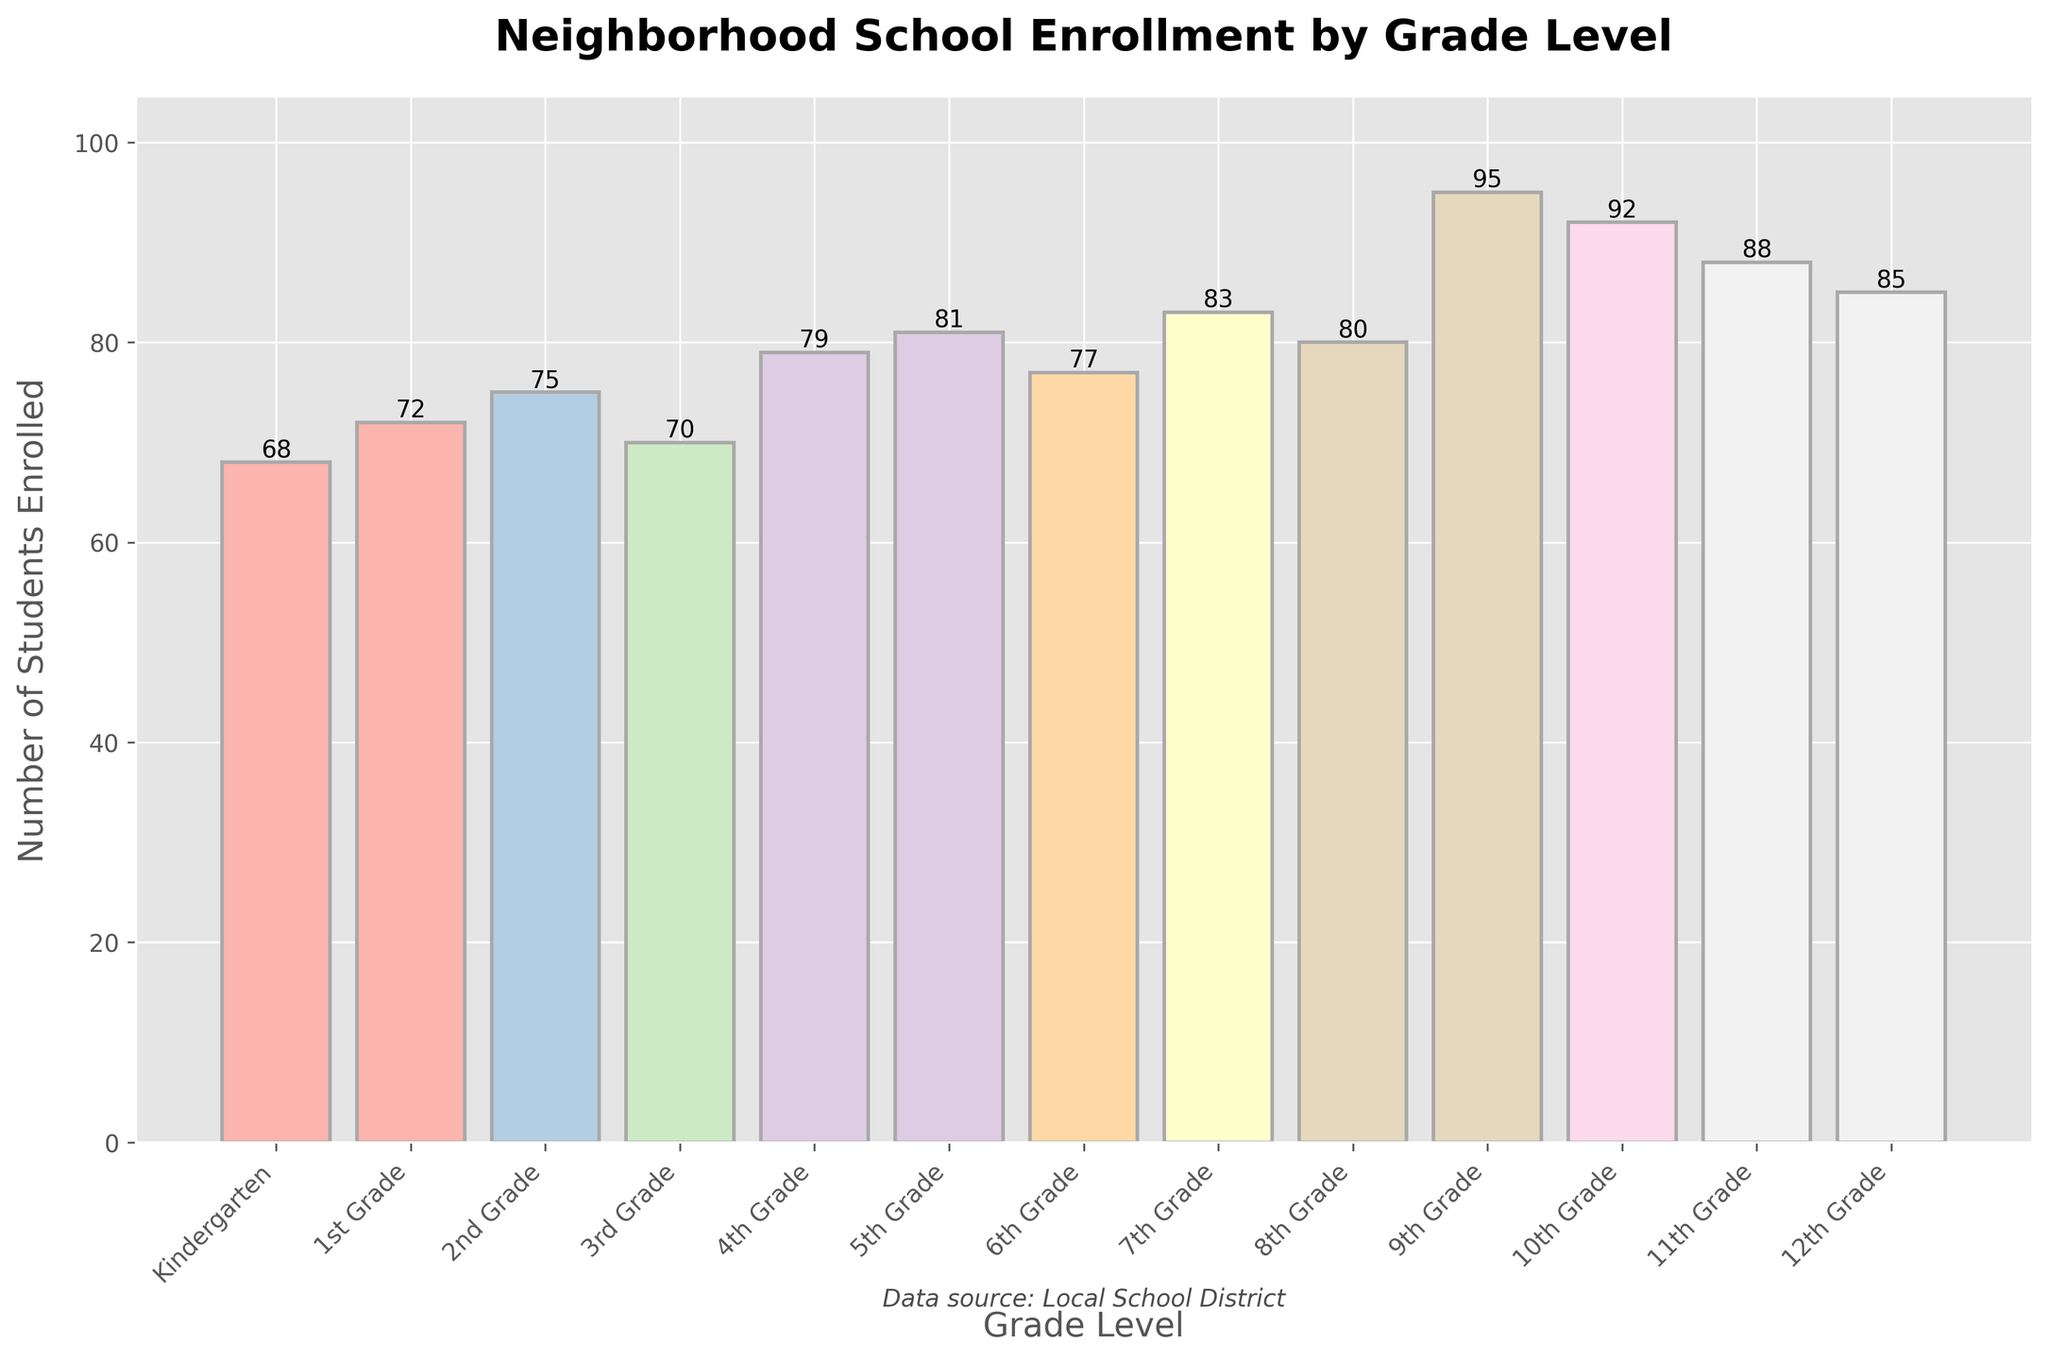Which grade has the highest enrollment? The tallest bar indicates the grade with the highest enrollment. According to the bar chart, 9th Grade has the highest enrollment.
Answer: 9th Grade Which grade has fewer students enrolled, 5th Grade or 6th Grade? By comparing the two bars for 5th Grade and 6th Grade, the bar for 6th Grade is shorter than the bar for 5th Grade.
Answer: 6th Grade How many more students are enrolled in 12th Grade compared to 3rd Grade? The number of students in 12th Grade is 85, and in 3rd Grade, it is 70. Subtract 70 from 85 which results in 15 more students in 12th Grade.
Answer: 15 Which grades have fewer than 75 students enrolled? The bars for Kindergarten, 1st Grade, 2nd Grade, and 3rd Grade are all below the 75-student level.
Answer: Kindergarten, 1st Grade, 2nd Grade, 3rd Grade What is the total number of students enrolled in 9th and 10th Grades combined? Add the number of students in 9th Grade (95) and 10th Grade (92). The combined total is 95 + 92 = 187.
Answer: 187 Which grade levels are taller than 8th Grade's bar in the chart? 8th Grade has 80 students. Grades 9th, 10th, 11th, and 12th each have taller bars with more students enrolled.
Answer: 9th Grade, 10th Grade, 11th Grade, 12th Grade What is the average number of students enrolled across all grades? Sum the enrollment numbers for all grades (68+72+75+70+79+81+77+83+80+95+92+88+85 = 1,045) and divide by the total number of grades (13). The average is 1,045 / 13 ≈ 80.4.
Answer: 80.4 By how much does 7th Grade enrollment exceed Kindergarten enrollment? The number of students in 7th Grade is 83, and in Kindergarten, it is 68. Subtract 68 from 83 to find that 7th Grade exceeds Kindergarten by 15 students.
Answer: 15 What is the difference between the total enrollment for grades K-5 and grades 6-12? First, calculate the total enrollment for K-5 grades (68+72+75+70+79+81 = 445) and for grades 6-12 (77+83+80+95+92+88+85 = 600). Then subtract 445 from 600 to find the difference.
Answer: 155 